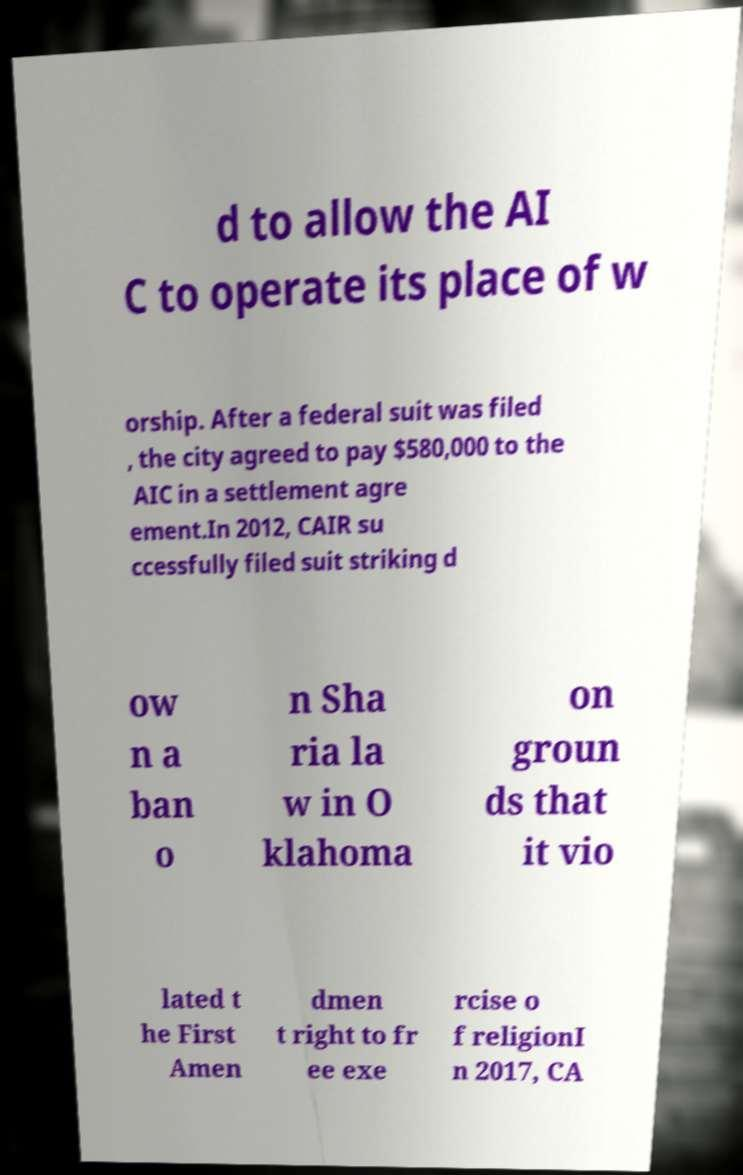Can you accurately transcribe the text from the provided image for me? d to allow the AI C to operate its place of w orship. After a federal suit was filed , the city agreed to pay $580,000 to the AIC in a settlement agre ement.In 2012, CAIR su ccessfully filed suit striking d ow n a ban o n Sha ria la w in O klahoma on groun ds that it vio lated t he First Amen dmen t right to fr ee exe rcise o f religionI n 2017, CA 